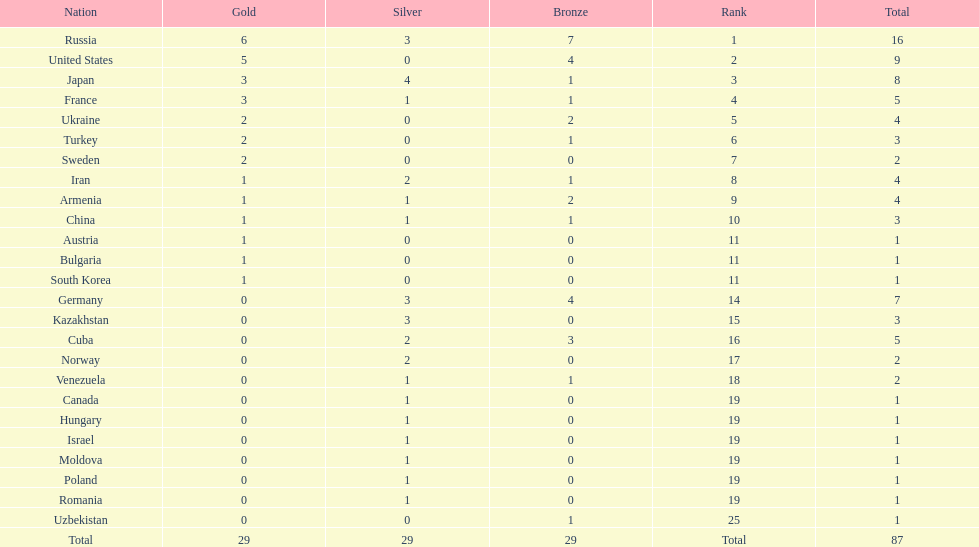How many silver medals did turkey win? 0. 